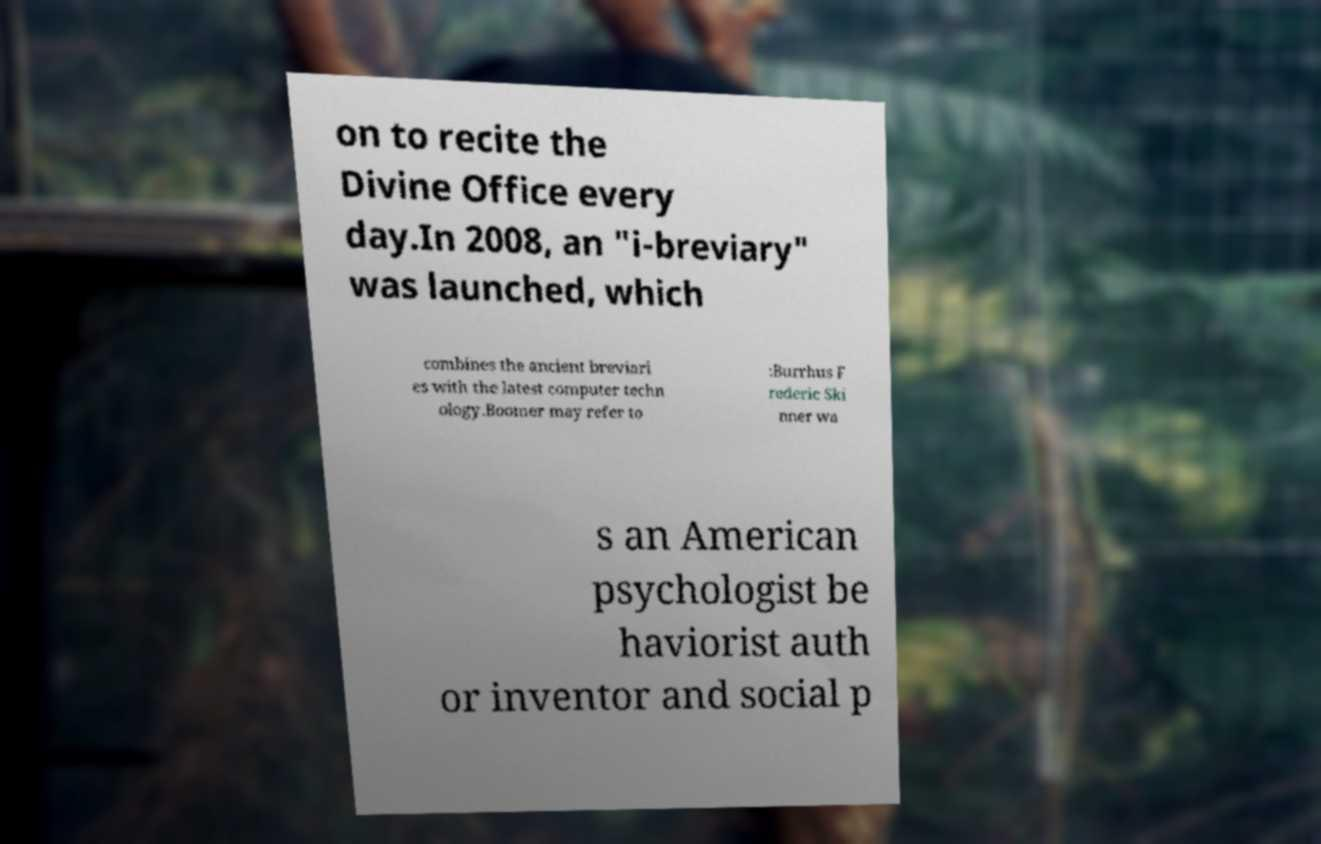Could you extract and type out the text from this image? on to recite the Divine Office every day.In 2008, an "i-breviary" was launched, which combines the ancient breviari es with the latest computer techn ology.Boomer may refer to :Burrhus F rederic Ski nner wa s an American psychologist be haviorist auth or inventor and social p 